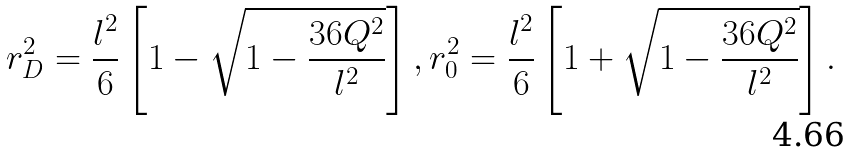<formula> <loc_0><loc_0><loc_500><loc_500>r _ { D } ^ { 2 } = \frac { l ^ { 2 } } { 6 } \left [ 1 - \sqrt { 1 - \frac { 3 6 Q ^ { 2 } } { l ^ { 2 } } } \right ] , r _ { 0 } ^ { 2 } = \frac { l ^ { 2 } } { 6 } \left [ 1 + \sqrt { 1 - \frac { 3 6 Q ^ { 2 } } { l ^ { 2 } } } \right ] .</formula> 